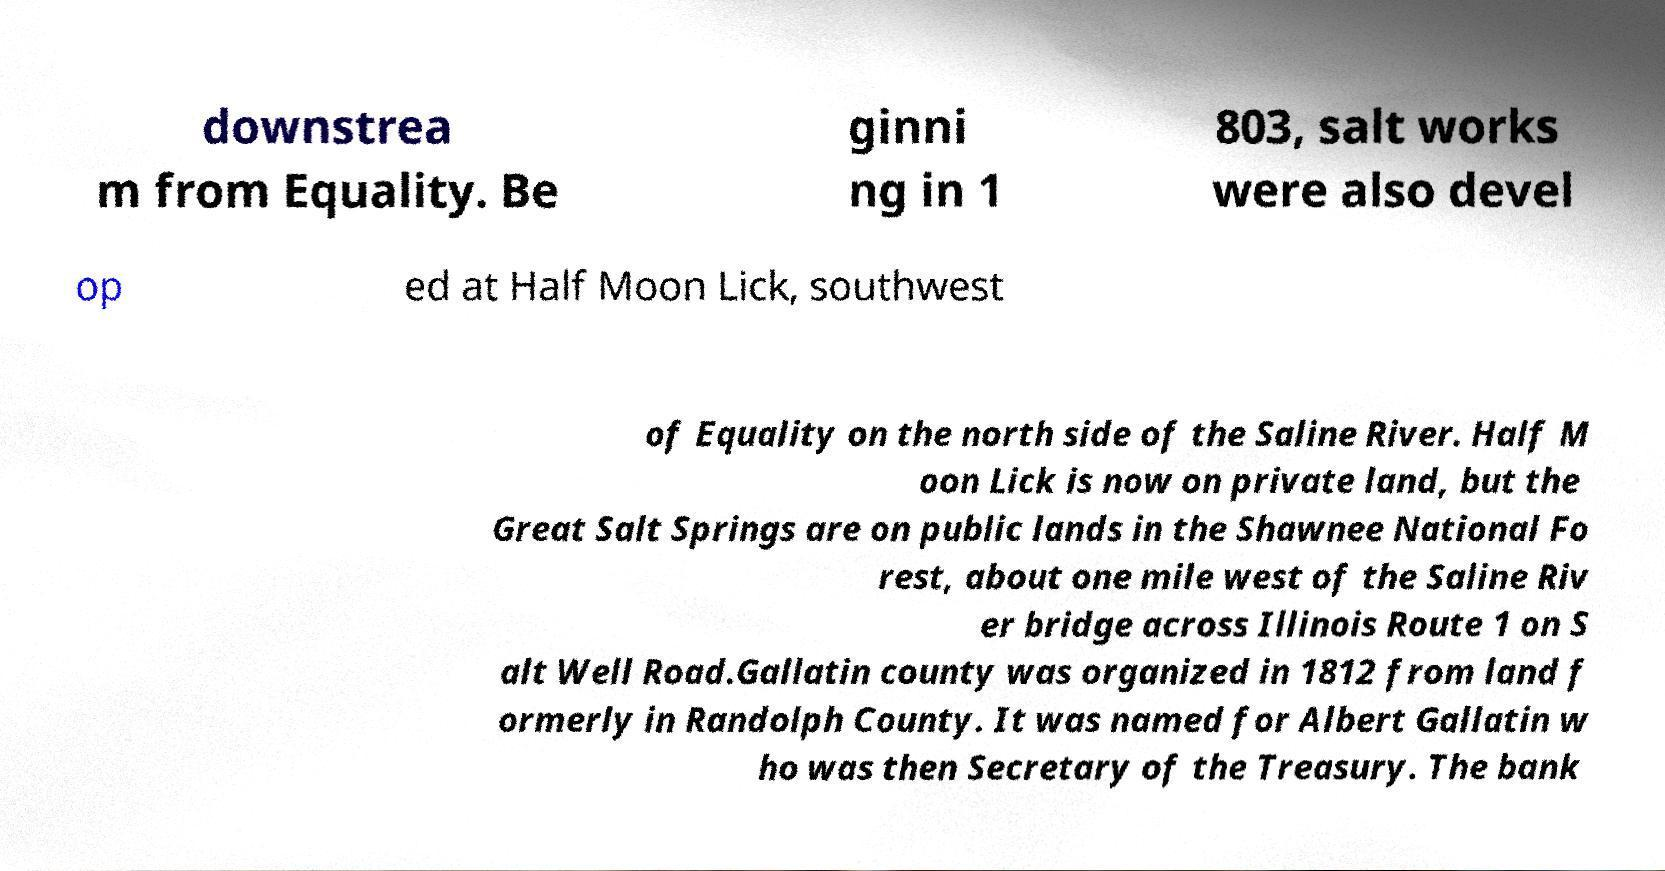Please read and relay the text visible in this image. What does it say? downstrea m from Equality. Be ginni ng in 1 803, salt works were also devel op ed at Half Moon Lick, southwest of Equality on the north side of the Saline River. Half M oon Lick is now on private land, but the Great Salt Springs are on public lands in the Shawnee National Fo rest, about one mile west of the Saline Riv er bridge across Illinois Route 1 on S alt Well Road.Gallatin county was organized in 1812 from land f ormerly in Randolph County. It was named for Albert Gallatin w ho was then Secretary of the Treasury. The bank 